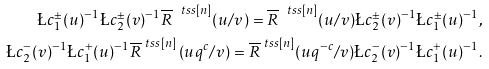Convert formula to latex. <formula><loc_0><loc_0><loc_500><loc_500>\L c ^ { \pm } _ { 1 } ( u ) ^ { - 1 } \L c ^ { \pm } _ { 2 } ( v ) ^ { - 1 } \overline { R } ^ { \ t s s [ n ] } ( u / v ) = \overline { R } ^ { \ t s s [ n ] } ( u / v ) \L c ^ { \pm } _ { 2 } ( v ) ^ { - 1 } \L c ^ { \pm } _ { 1 } ( u ) ^ { - 1 } , \\ \L c ^ { - } _ { 2 } ( v ) ^ { - 1 } \L c ^ { + } _ { 1 } ( u ) ^ { - 1 } \overline { R } ^ { \ t s s [ n ] } \left ( { u } q ^ { c } / v \right ) = \overline { R } ^ { \ t s s [ n ] } ( { u } q ^ { - c } / v ) \L c ^ { - } _ { 2 } ( v ) ^ { - 1 } \L c ^ { + } _ { 1 } ( u ) ^ { - 1 } .</formula> 